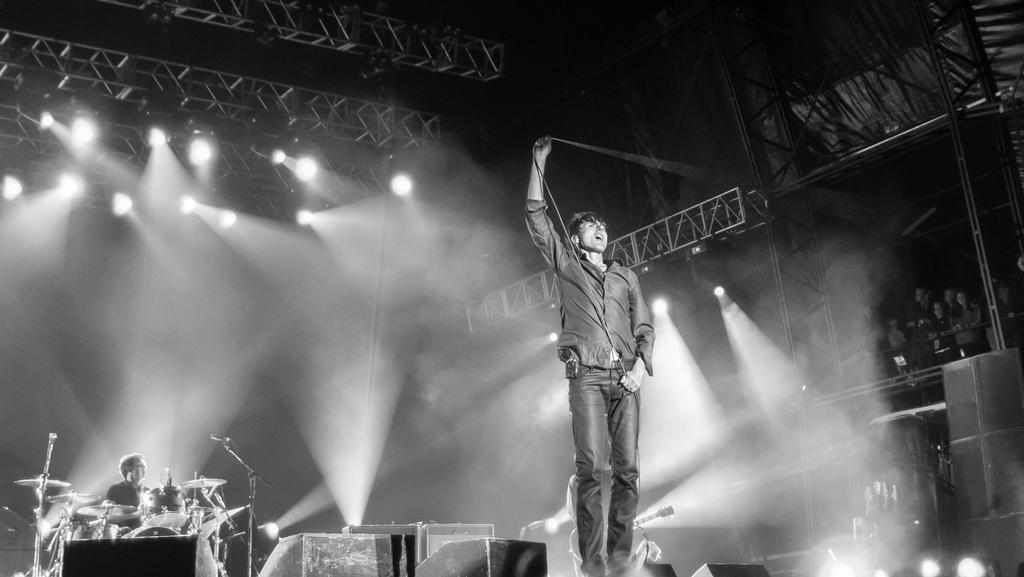Could you give a brief overview of what you see in this image? In this black and white picture there is a person standing in the middle of the image. He is holding a wire in his hand. Behind him there is a person holding a guitar. Left side there is a person behind the musical instrument. Right bottom there are few lights. Left side there are few lights attached to the metal rods. 